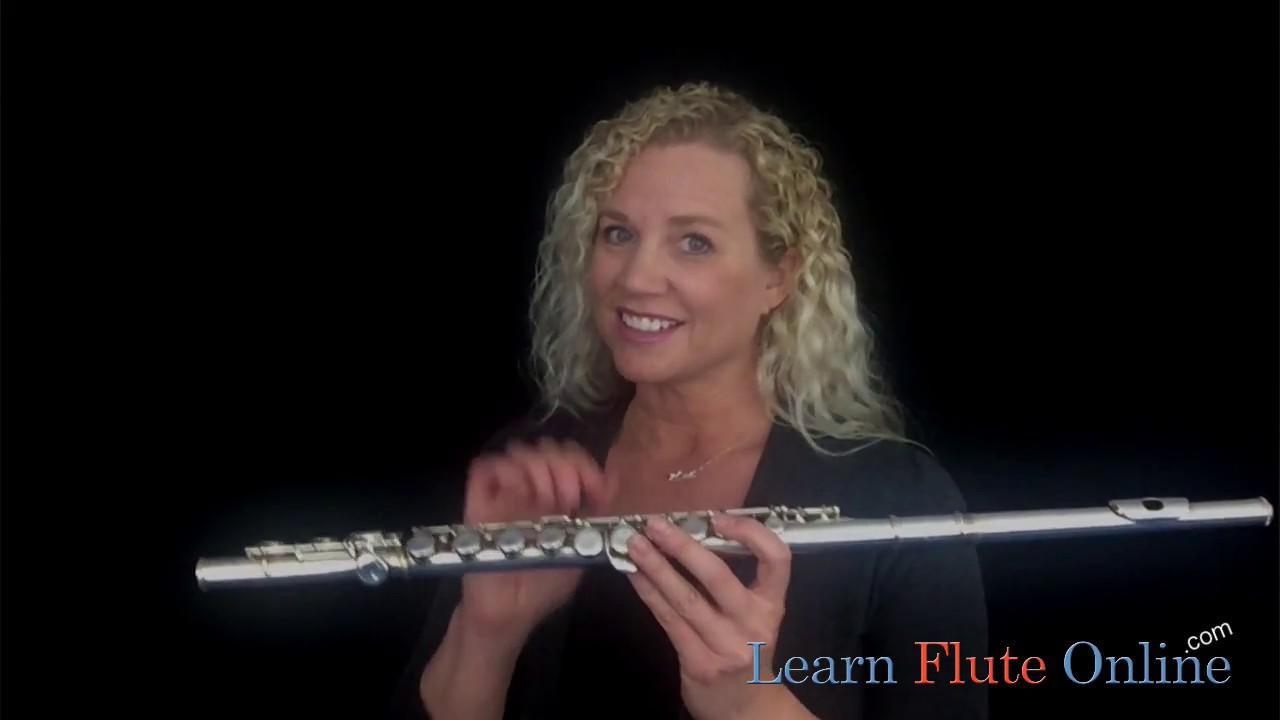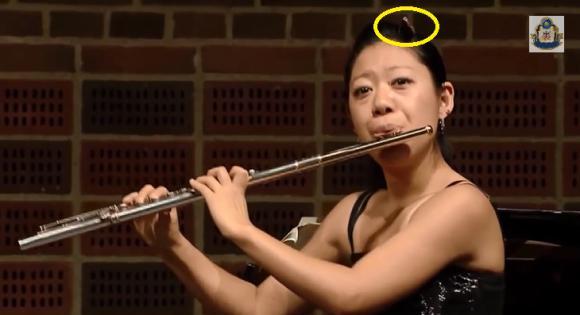The first image is the image on the left, the second image is the image on the right. Examine the images to the left and right. Is the description "In at least one image there is a woman with long hair  holding but no playing the flute." accurate? Answer yes or no. Yes. The first image is the image on the left, the second image is the image on the right. Examine the images to the left and right. Is the description "A woman smiles while she holds a flute in one of the images." accurate? Answer yes or no. Yes. 